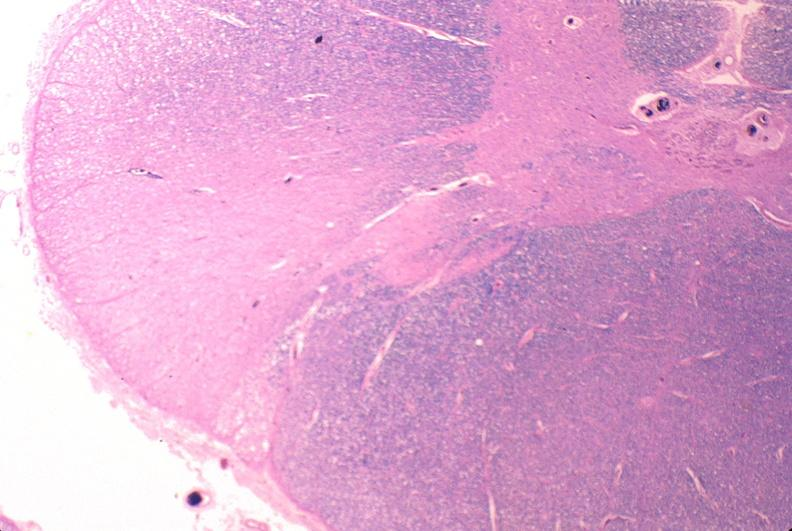why does this image show spinal cord injury?
Answer the question using a single word or phrase. Due to vertebral column trauma 